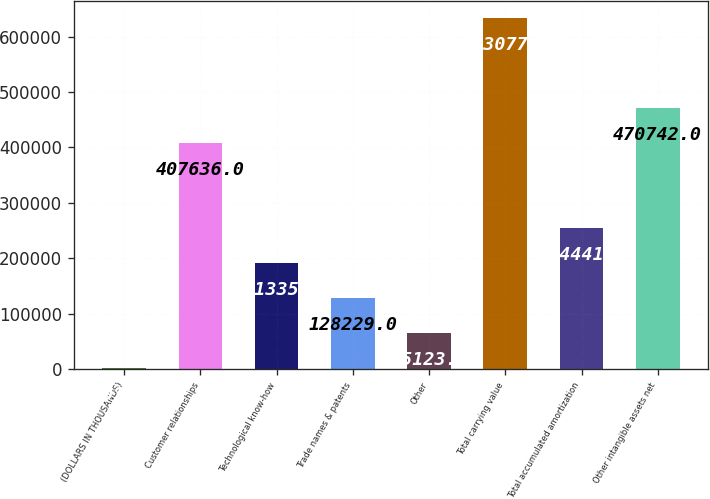Convert chart. <chart><loc_0><loc_0><loc_500><loc_500><bar_chart><fcel>(DOLLARS IN THOUSANDS)<fcel>Customer relationships<fcel>Technological know-how<fcel>Trade names & patents<fcel>Other<fcel>Total carrying value<fcel>Total accumulated amortization<fcel>Other intangible assets net<nl><fcel>2017<fcel>407636<fcel>191335<fcel>128229<fcel>65123<fcel>633077<fcel>254441<fcel>470742<nl></chart> 